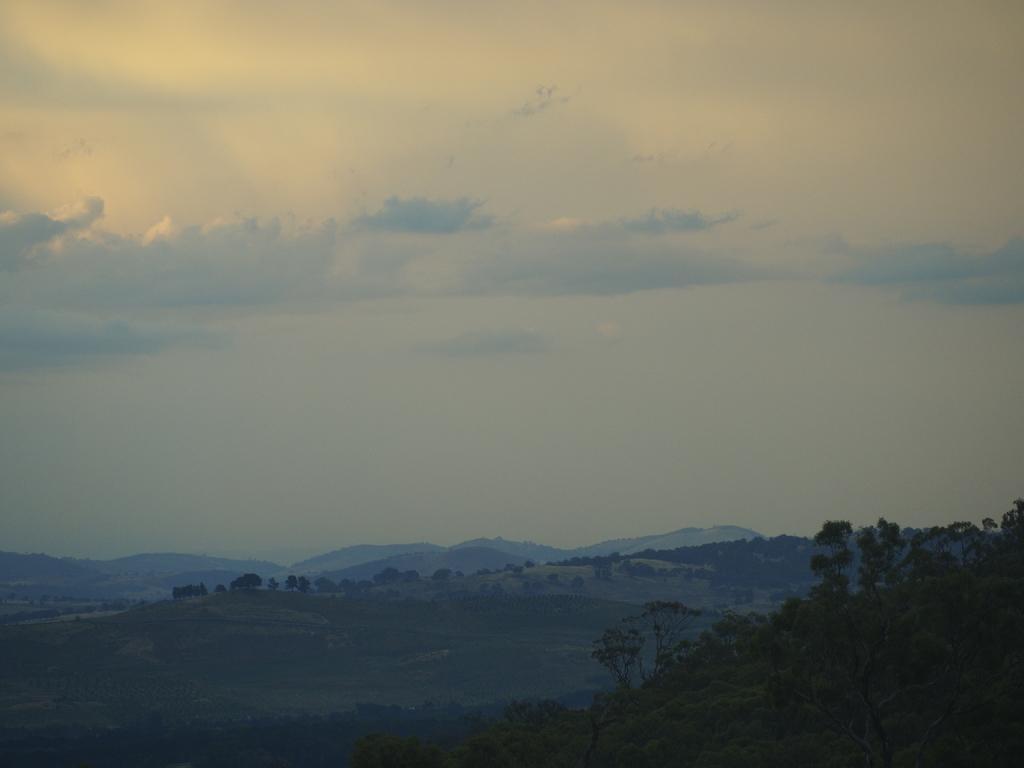Can you describe this image briefly? In this image there is full of greenery. There are trees. There is grass. There are mountains. There are clouds in the sky. 